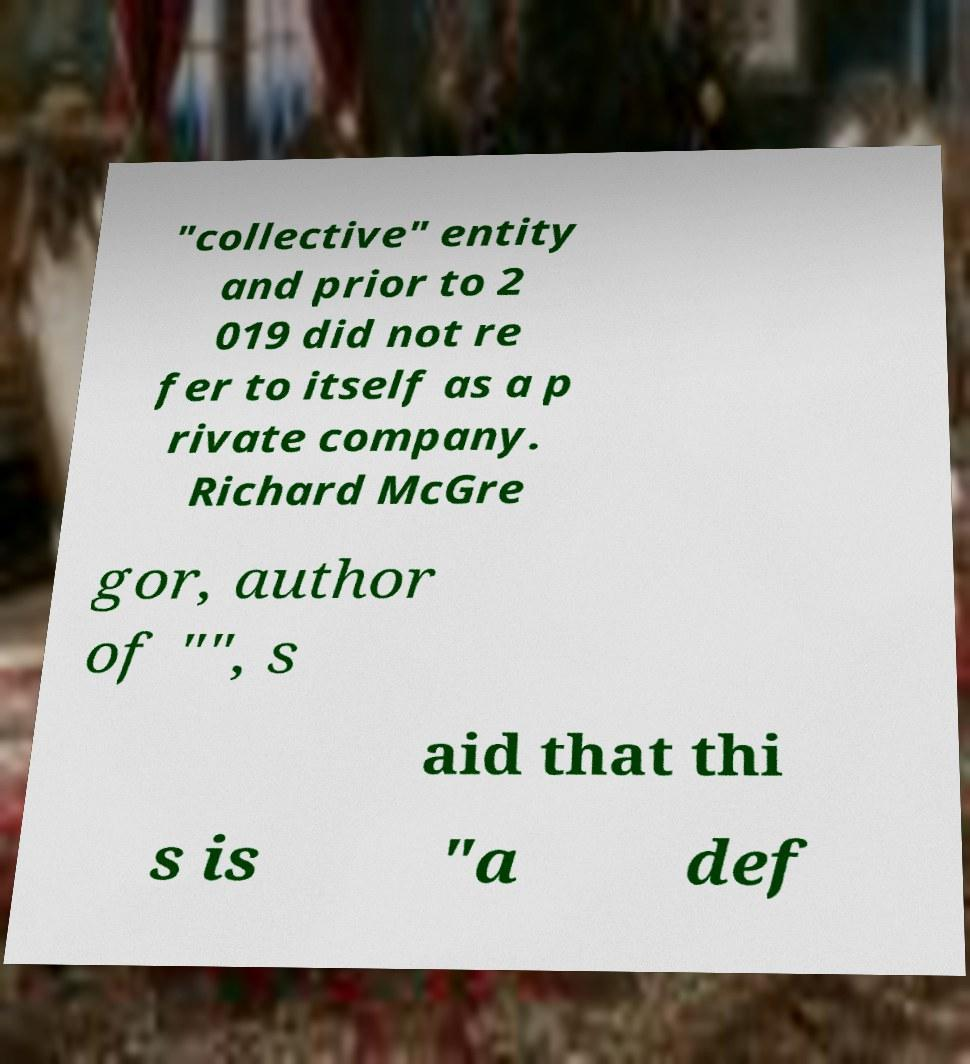Could you assist in decoding the text presented in this image and type it out clearly? "collective" entity and prior to 2 019 did not re fer to itself as a p rivate company. Richard McGre gor, author of "", s aid that thi s is "a def 